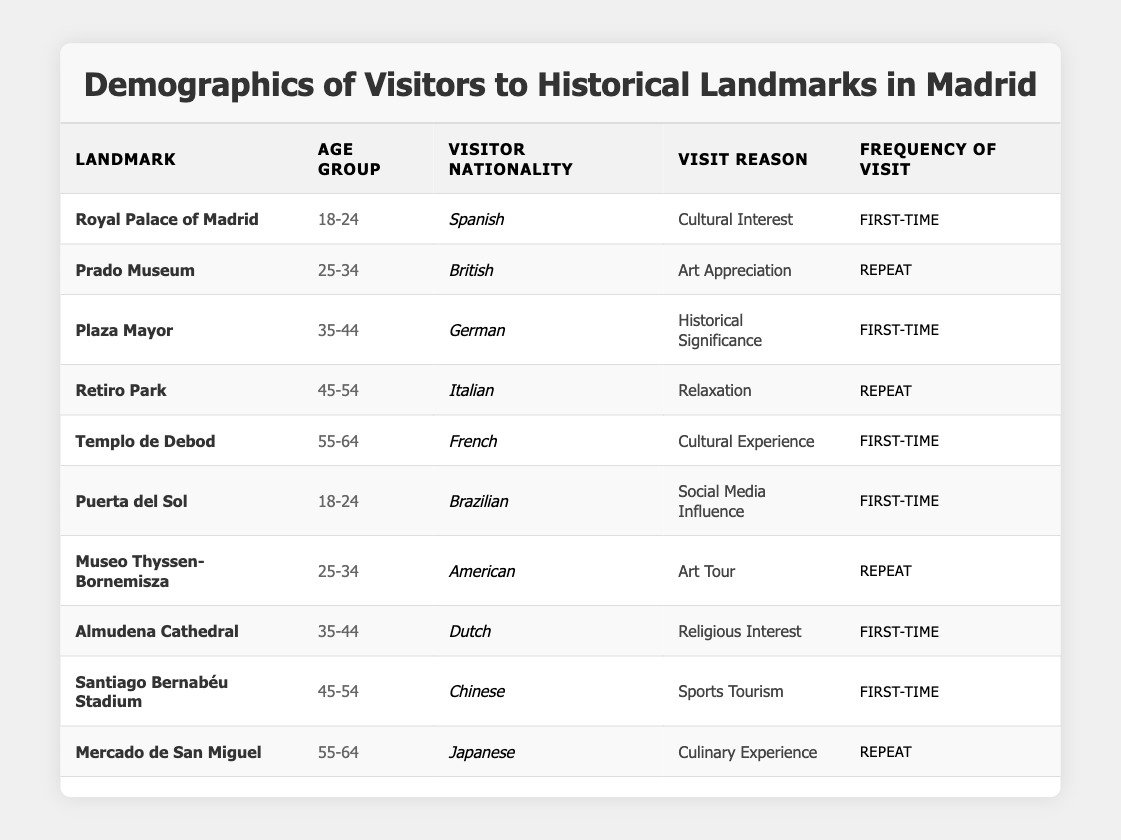What is the most common visit reason for visitors to the Royal Palace of Madrid? In the table, the Royal Palace of Madrid has one listed reason for the visit, which is "Cultural Interest." Therefore, it is the only visit reason for this landmark.
Answer: Cultural Interest How many visitors to the Prado Museum are from the British nationality? The table shows that there is one entry for the Prado Museum, and it is attributed to a British visitor.
Answer: 1 Which age group has the highest number of first-time visitors? The table contains five first-time visitors. They are from the age groups 18-24, 35-44, 55-64, and 45-54. When counted, it results in four distinct groups with one entry each, meaning no age group is repeated for first-time visits.
Answer: None (there is no single age group with the highest count) Is there a visitor from Brazil among the listed nationalities? Yes, the table lists a visitor from Brazil who visited Puerta del Sol, confirming that there is at least one entry from that nationality.
Answer: Yes Which two landmarks have repeat visitors, and how many total entries do they have? The table indicates that the Prado Museum and Mercado de San Miguel have repeat visitors. They each have one entry, totaling two repeat entries: one for each landmark.
Answer: 2 What percentage of total visitors are from the age group 55-64? There are 10 total visitors, and the age group 55-64 has 3 entries (Templo de Debod, Mercado de San Miguel). To calculate the percentage: (3/10) * 100 = 30%.
Answer: 30% What is the nationality of the visitor with the highest age group visiting the Templo de Debod? The Templo de Debod is visited by a French national from the age group 55-64, making it the only entry from this age group for this landmark.
Answer: French Do visitors primarily visit the landmarks for cultural experiences? By reviewing the reasons listed, "Cultural Experience" is one of the reasons, but there are different ones like "Art Appreciation," "Historical Significance," and "Social Media Influence." Since there are multiple reasons, cultural experiences are not the primary reason overall.
Answer: No What landmarks have visitors aged 45-54, and what are their visit reasons? Reviewing the table, visitors aged 45-54 visited Retiro Park (Relaxation) and Santiago Bernabéu Stadium (Sports Tourism).
Answer: Retiro Park (Relaxation), Santiago Bernabéu Stadium (Sports Tourism) How many distinct nationalities are represented among the first-time visitors? The distinct nationalities among first-time visitors are Spanish, German, French, Brazilian, Dutch, and Chinese, totaling six unique nationalities across the entries.
Answer: 6 Which age group has visitors represented in both repeat and first-time categories? The age group 25-34 has one repeat visitor from the American nationality at Museo Thyssen-Bornemisza, while there are no visitors from this age group recorded in the first-time column.
Answer: None 